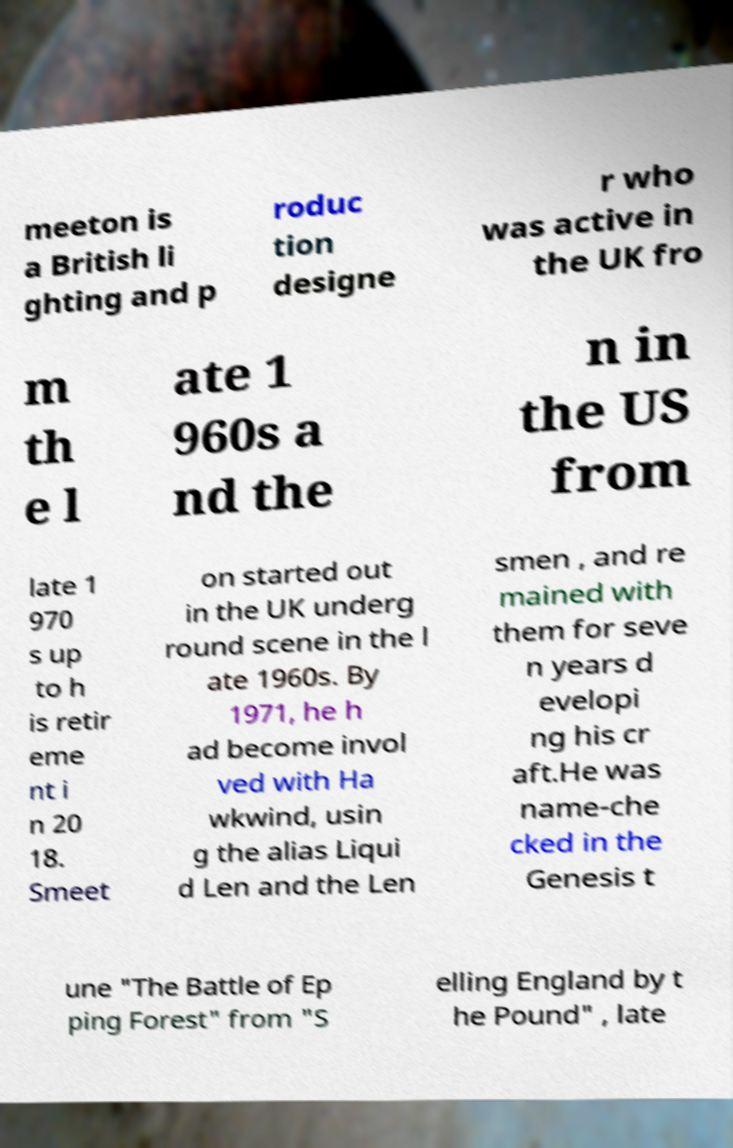Please identify and transcribe the text found in this image. meeton is a British li ghting and p roduc tion designe r who was active in the UK fro m th e l ate 1 960s a nd the n in the US from late 1 970 s up to h is retir eme nt i n 20 18. Smeet on started out in the UK underg round scene in the l ate 1960s. By 1971, he h ad become invol ved with Ha wkwind, usin g the alias Liqui d Len and the Len smen , and re mained with them for seve n years d evelopi ng his cr aft.He was name-che cked in the Genesis t une "The Battle of Ep ping Forest" from "S elling England by t he Pound" , late 